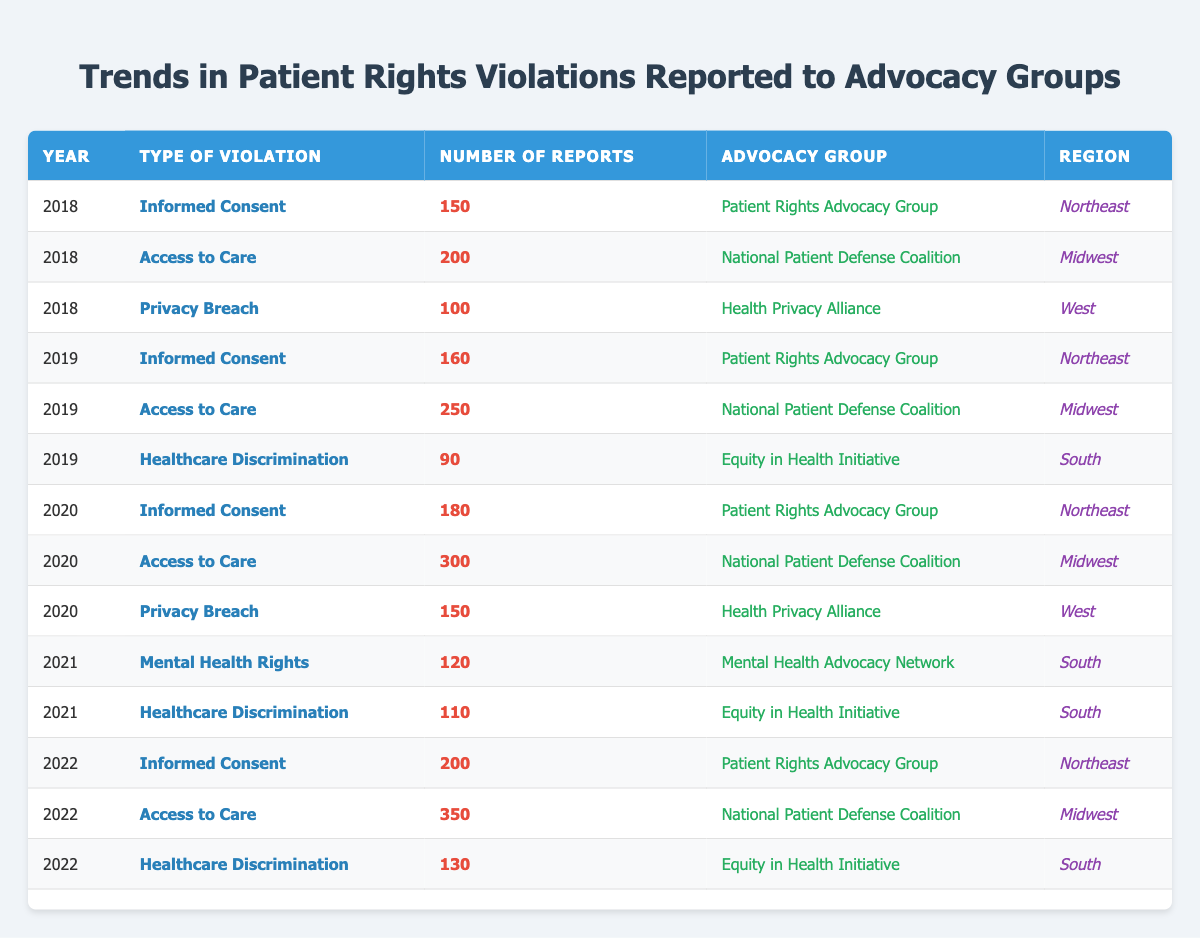What were the number of reports for Informed Consent violations in 2020? In 2020, the table shows that there were 180 reports for Informed Consent violations specifically under the Patient Rights Advocacy Group in the Northeast region.
Answer: 180 Which advocacy group reported the highest number of Access to Care violations in 2022? In the table, the National Patient Defense Coalition reported 350 Access to Care violations in 2022, which is higher than any other advocacy group in that year.
Answer: National Patient Defense Coalition Was there an increase in the number of Informed Consent reports from 2019 to 2020? The data shows that the number of Informed Consent reports increased from 160 in 2019 to 180 in 2020, indicating a rise of 20 reports in that category.
Answer: Yes How many total Healthcare Discrimination reports were filed over the years 2019 to 2022? Adding the Healthcare Discrimination reports from each relevant year: 90 (2019) + 110 (2021) + 130 (2022) gives a total of 330 reports over those years.
Answer: 330 In which region was the lowest number of Privacy Breach reports recorded, and what was that number? The lowest number of Privacy Breach reports occurred in the West region with 100 reports in 2018, which is lower than the 150 reports recorded in 2020 in the same region.
Answer: 100 What was the average number of reports for Mental Health Rights violations from 2021? There was only one entry for Mental Health Rights violations in 2021, which was 120 reports. Hence, the average for that year is simply that one value.
Answer: 120 Did the Northeast region have the most total reports for Informed Consent violations from 2018 to 2022? Reviewing the totals from the Northeast for those years: 150 (2018) + 160 (2019) + 180 (2020) + 200 (2022) = 690. There is no comparable total for any other region for that category in those years, confirming that the Northeast had the most.
Answer: Yes Which year saw the largest increase in Access to Care reports compared to the previous year? By comparing the reports: 200 (2018) to 250 (2019) is an increase of 50; from 2019 to 2020: 250 to 300 is a 50 increase; and from 2020 to 2022 the increase was from 300 to 350, which is a 50 increase too. Since all these years represent the same increase, we conclude that 2019, 2020, and 2022 all share the largest increase of 50.
Answer: 2019, 2020, 2022 